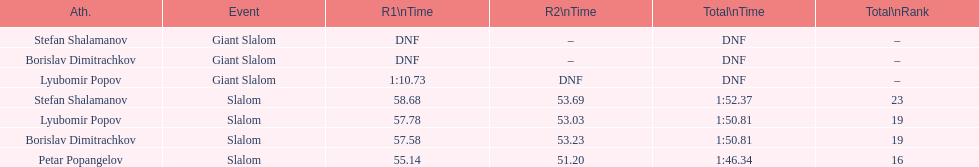How many minutes or seconds did it take lyubomir popov to conclude the giant slalom during the initial race? 1:10.73. 